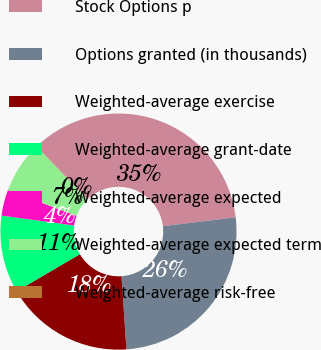<chart> <loc_0><loc_0><loc_500><loc_500><pie_chart><fcel>Stock Options p<fcel>Options granted (in thousands)<fcel>Weighted-average exercise<fcel>Weighted-average grant-date<fcel>Weighted-average expected<fcel>Weighted-average expected term<fcel>Weighted-average risk-free<nl><fcel>35.24%<fcel>25.86%<fcel>17.64%<fcel>10.6%<fcel>3.56%<fcel>7.08%<fcel>0.04%<nl></chart> 